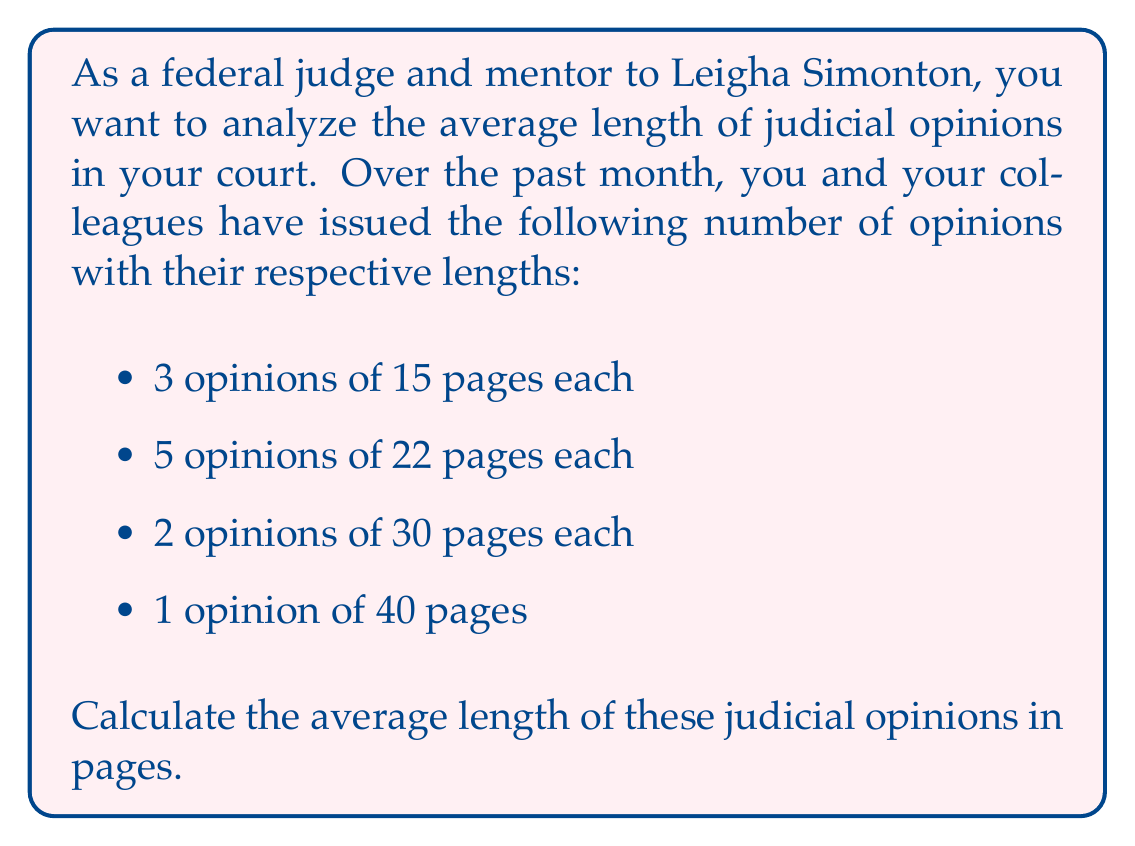Provide a solution to this math problem. To calculate the average length of the judicial opinions, we need to follow these steps:

1. Calculate the total number of opinions:
   $3 + 5 + 2 + 1 = 11$ opinions

2. Calculate the total number of pages:
   $(3 \times 15) + (5 \times 22) + (2 \times 30) + (1 \times 40)$
   $= 45 + 110 + 60 + 40$
   $= 255$ pages

3. Calculate the average by dividing the total number of pages by the total number of opinions:

   $$\text{Average} = \frac{\text{Total pages}}{\text{Total opinions}} = \frac{255}{11}$$

4. Perform the division:
   $\frac{255}{11} = 23.18181...$

5. Round to two decimal places:
   $23.18$ pages

Therefore, the average length of the judicial opinions is 23.18 pages.
Answer: $23.18$ pages 